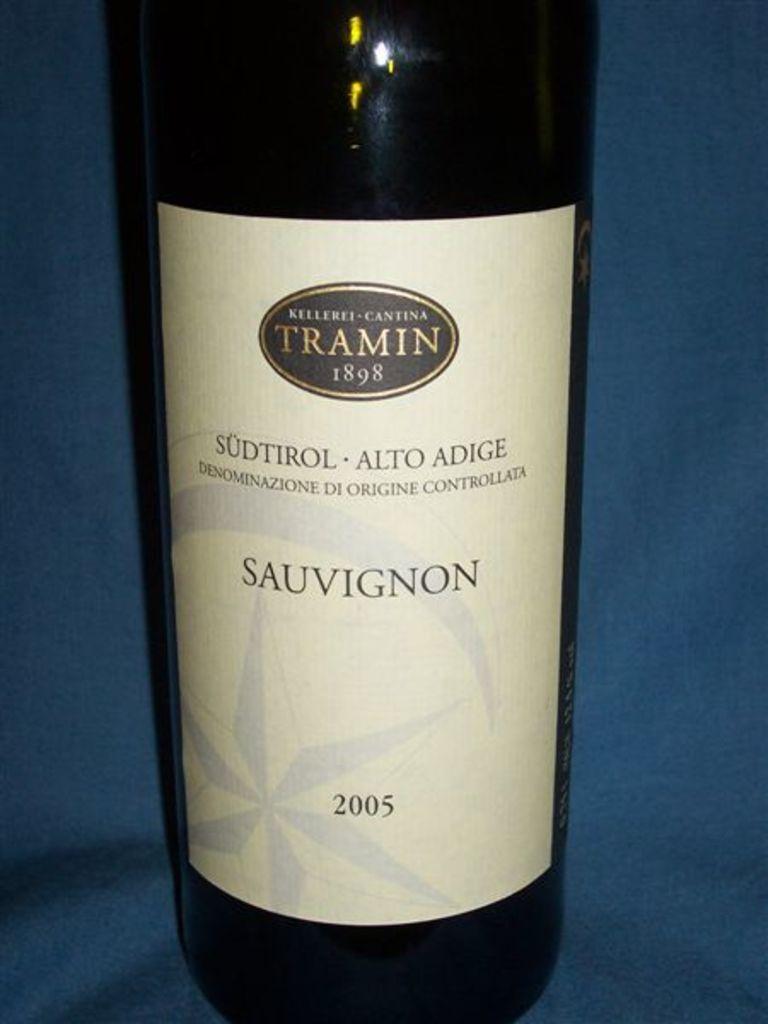What year did tramin start?
Make the answer very short. 1898. This is win and drinks?
Your response must be concise. Yes. 